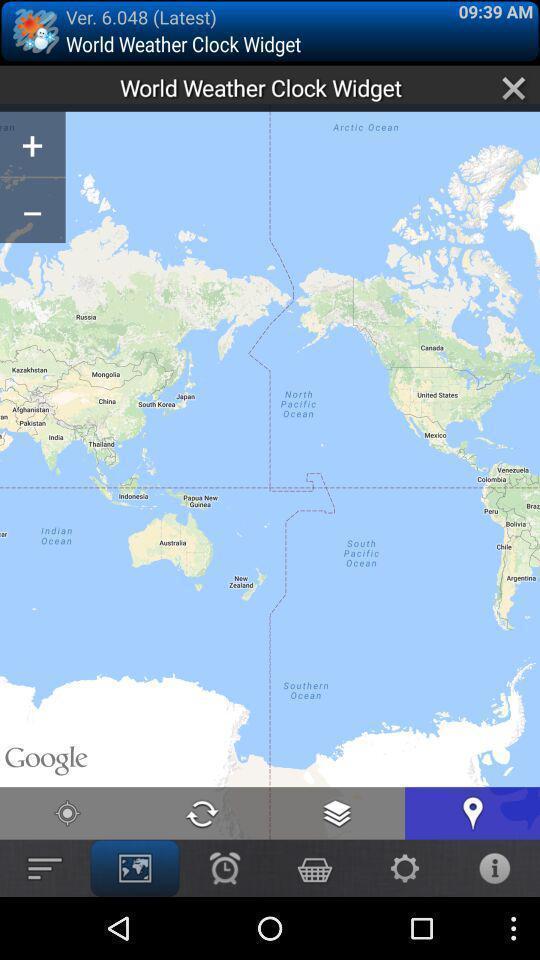Give me a narrative description of this picture. Screen displaying map in app. 